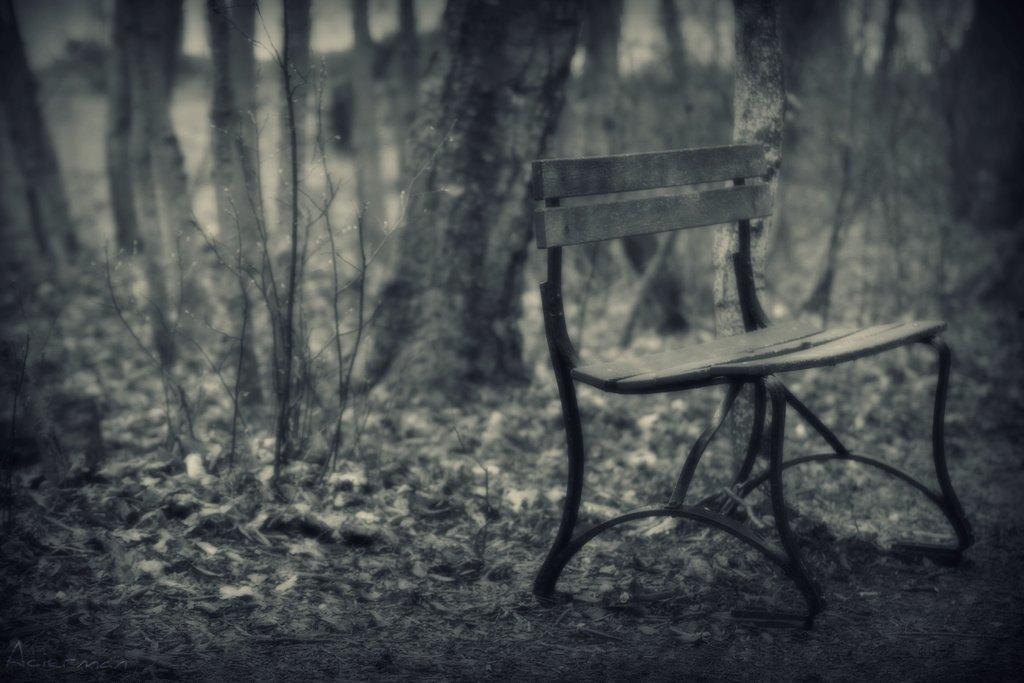How would you summarize this image in a sentence or two? In this image there is a bench. In the background there are trees and we can see a plant. 